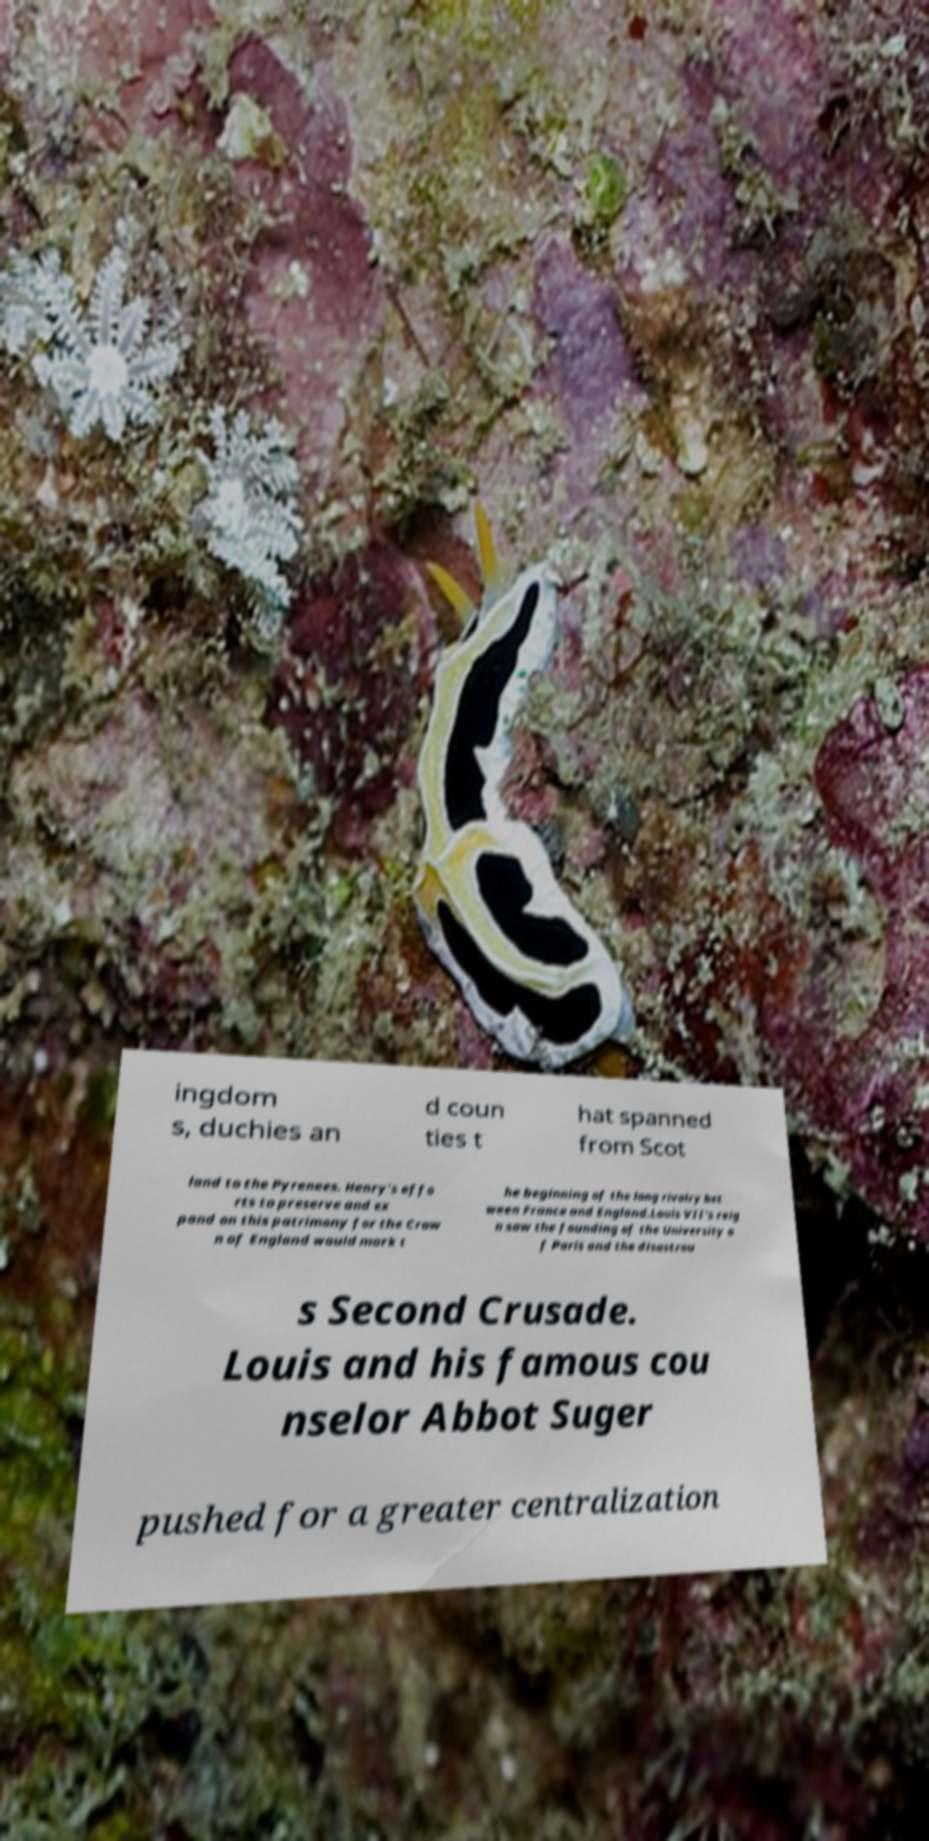For documentation purposes, I need the text within this image transcribed. Could you provide that? ingdom s, duchies an d coun ties t hat spanned from Scot land to the Pyrenees. Henry's effo rts to preserve and ex pand on this patrimony for the Crow n of England would mark t he beginning of the long rivalry bet ween France and England.Louis VII's reig n saw the founding of the University o f Paris and the disastrou s Second Crusade. Louis and his famous cou nselor Abbot Suger pushed for a greater centralization 